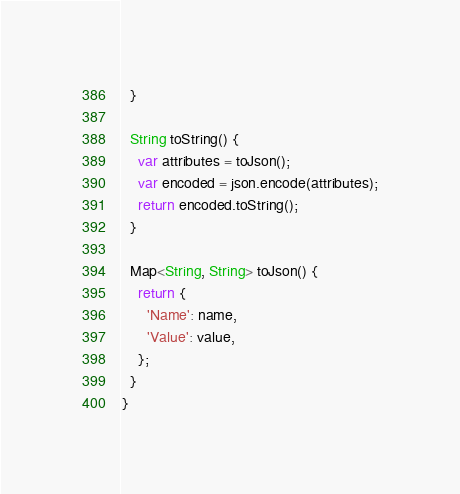Convert code to text. <code><loc_0><loc_0><loc_500><loc_500><_Dart_>  }

  String toString() {
    var attributes = toJson();
    var encoded = json.encode(attributes);
    return encoded.toString();
  }

  Map<String, String> toJson() {
    return {
      'Name': name,
      'Value': value,
    };
  }
}
</code> 